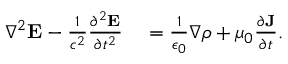<formula> <loc_0><loc_0><loc_500><loc_500>\begin{array} { r l } { \nabla ^ { 2 } { \mathbf E } - \frac { 1 } { c ^ { 2 } } \frac { \partial ^ { 2 } { \mathbf E } } { \partial t ^ { 2 } } } & = \frac { 1 } { \epsilon _ { 0 } } \nabla \rho + \mu _ { 0 } \frac { \partial { \mathbf J } } { \partial t } . } \end{array}</formula> 